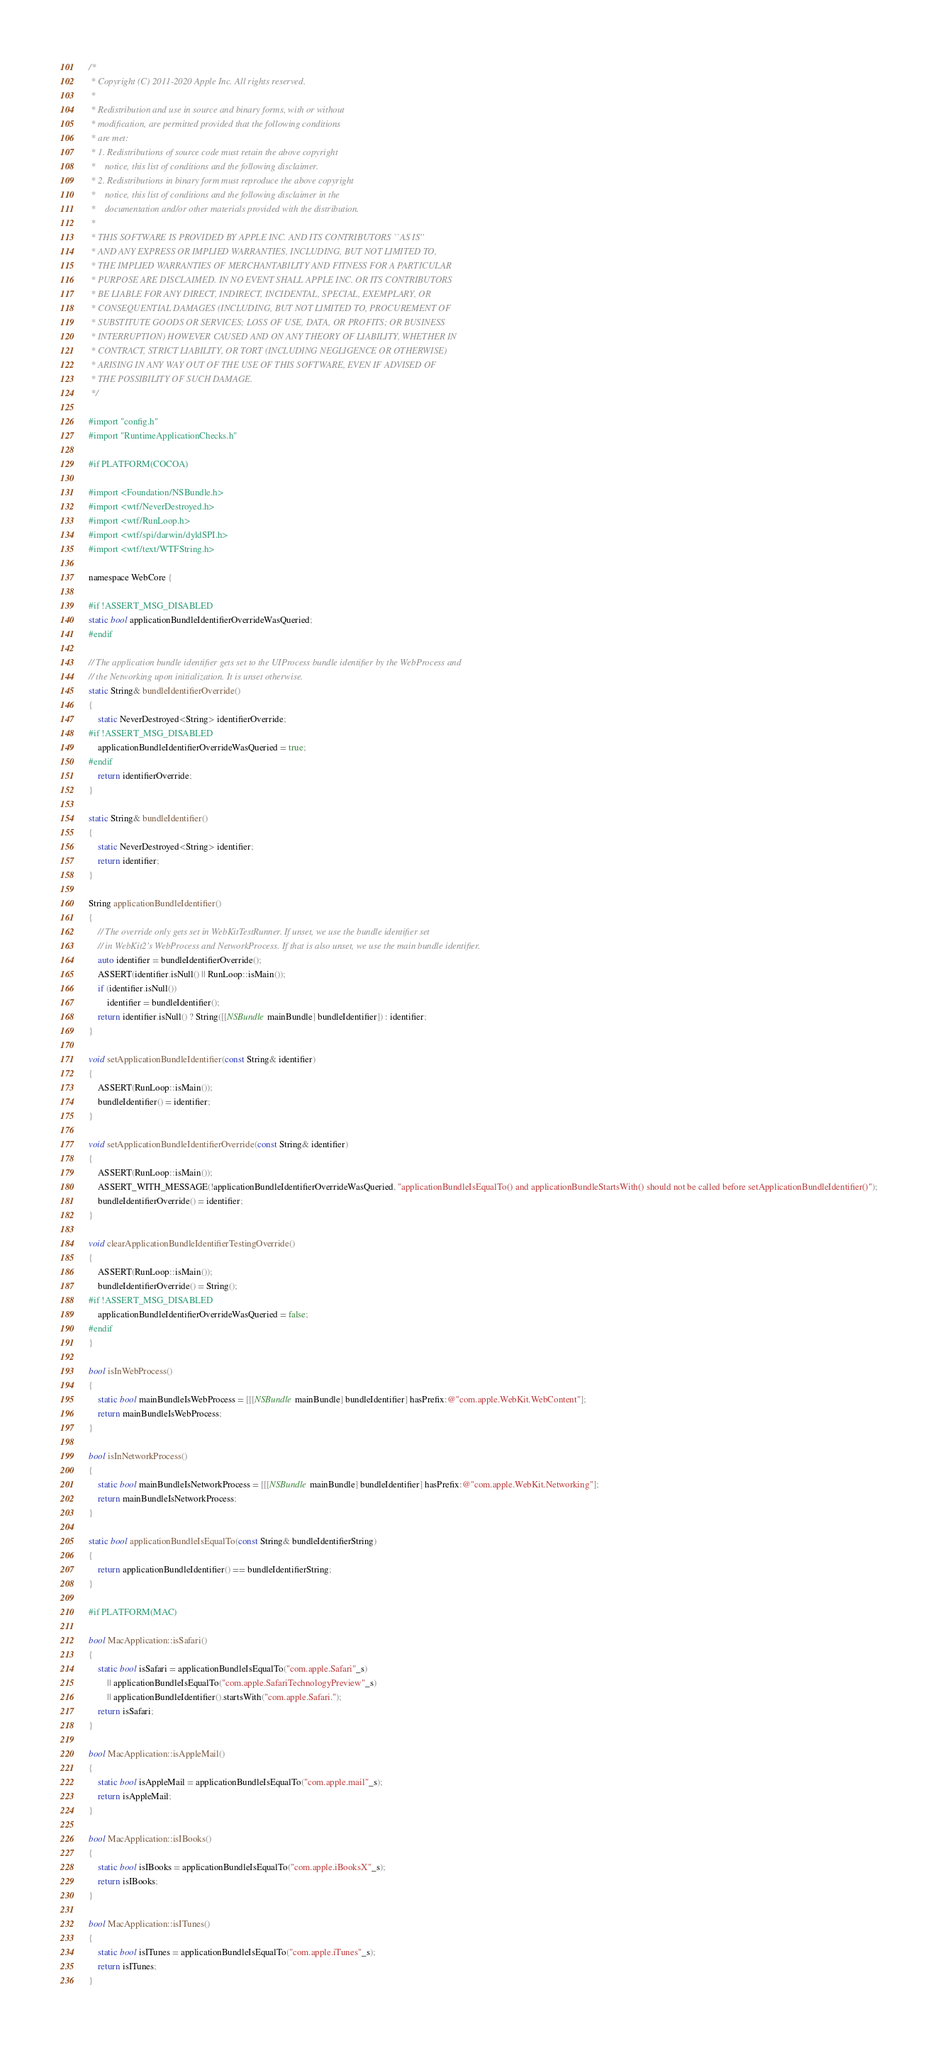Convert code to text. <code><loc_0><loc_0><loc_500><loc_500><_ObjectiveC_>/*
 * Copyright (C) 2011-2020 Apple Inc. All rights reserved.
 *
 * Redistribution and use in source and binary forms, with or without
 * modification, are permitted provided that the following conditions
 * are met:
 * 1. Redistributions of source code must retain the above copyright
 *    notice, this list of conditions and the following disclaimer.
 * 2. Redistributions in binary form must reproduce the above copyright
 *    notice, this list of conditions and the following disclaimer in the
 *    documentation and/or other materials provided with the distribution.
 *
 * THIS SOFTWARE IS PROVIDED BY APPLE INC. AND ITS CONTRIBUTORS ``AS IS''
 * AND ANY EXPRESS OR IMPLIED WARRANTIES, INCLUDING, BUT NOT LIMITED TO,
 * THE IMPLIED WARRANTIES OF MERCHANTABILITY AND FITNESS FOR A PARTICULAR
 * PURPOSE ARE DISCLAIMED. IN NO EVENT SHALL APPLE INC. OR ITS CONTRIBUTORS
 * BE LIABLE FOR ANY DIRECT, INDIRECT, INCIDENTAL, SPECIAL, EXEMPLARY, OR
 * CONSEQUENTIAL DAMAGES (INCLUDING, BUT NOT LIMITED TO, PROCUREMENT OF
 * SUBSTITUTE GOODS OR SERVICES; LOSS OF USE, DATA, OR PROFITS; OR BUSINESS
 * INTERRUPTION) HOWEVER CAUSED AND ON ANY THEORY OF LIABILITY, WHETHER IN
 * CONTRACT, STRICT LIABILITY, OR TORT (INCLUDING NEGLIGENCE OR OTHERWISE)
 * ARISING IN ANY WAY OUT OF THE USE OF THIS SOFTWARE, EVEN IF ADVISED OF
 * THE POSSIBILITY OF SUCH DAMAGE.
 */

#import "config.h"
#import "RuntimeApplicationChecks.h"

#if PLATFORM(COCOA)

#import <Foundation/NSBundle.h>
#import <wtf/NeverDestroyed.h>
#import <wtf/RunLoop.h>
#import <wtf/spi/darwin/dyldSPI.h>
#import <wtf/text/WTFString.h>

namespace WebCore {

#if !ASSERT_MSG_DISABLED
static bool applicationBundleIdentifierOverrideWasQueried;
#endif

// The application bundle identifier gets set to the UIProcess bundle identifier by the WebProcess and
// the Networking upon initialization. It is unset otherwise.
static String& bundleIdentifierOverride()
{
    static NeverDestroyed<String> identifierOverride;
#if !ASSERT_MSG_DISABLED
    applicationBundleIdentifierOverrideWasQueried = true;
#endif
    return identifierOverride;
}

static String& bundleIdentifier()
{
    static NeverDestroyed<String> identifier;
    return identifier;
}

String applicationBundleIdentifier()
{
    // The override only gets set in WebKitTestRunner. If unset, we use the bundle identifier set
    // in WebKit2's WebProcess and NetworkProcess. If that is also unset, we use the main bundle identifier.
    auto identifier = bundleIdentifierOverride();
    ASSERT(identifier.isNull() || RunLoop::isMain());
    if (identifier.isNull())
        identifier = bundleIdentifier();
    return identifier.isNull() ? String([[NSBundle mainBundle] bundleIdentifier]) : identifier;
}

void setApplicationBundleIdentifier(const String& identifier)
{
    ASSERT(RunLoop::isMain());
    bundleIdentifier() = identifier;
}

void setApplicationBundleIdentifierOverride(const String& identifier)
{
    ASSERT(RunLoop::isMain());
    ASSERT_WITH_MESSAGE(!applicationBundleIdentifierOverrideWasQueried, "applicationBundleIsEqualTo() and applicationBundleStartsWith() should not be called before setApplicationBundleIdentifier()");
    bundleIdentifierOverride() = identifier;
}

void clearApplicationBundleIdentifierTestingOverride()
{
    ASSERT(RunLoop::isMain());
    bundleIdentifierOverride() = String();
#if !ASSERT_MSG_DISABLED
    applicationBundleIdentifierOverrideWasQueried = false;
#endif
}

bool isInWebProcess()
{
    static bool mainBundleIsWebProcess = [[[NSBundle mainBundle] bundleIdentifier] hasPrefix:@"com.apple.WebKit.WebContent"];
    return mainBundleIsWebProcess;
}

bool isInNetworkProcess()
{
    static bool mainBundleIsNetworkProcess = [[[NSBundle mainBundle] bundleIdentifier] hasPrefix:@"com.apple.WebKit.Networking"];
    return mainBundleIsNetworkProcess;
}

static bool applicationBundleIsEqualTo(const String& bundleIdentifierString)
{
    return applicationBundleIdentifier() == bundleIdentifierString;
}

#if PLATFORM(MAC)

bool MacApplication::isSafari()
{
    static bool isSafari = applicationBundleIsEqualTo("com.apple.Safari"_s)
        || applicationBundleIsEqualTo("com.apple.SafariTechnologyPreview"_s)
        || applicationBundleIdentifier().startsWith("com.apple.Safari.");
    return isSafari;
}

bool MacApplication::isAppleMail()
{
    static bool isAppleMail = applicationBundleIsEqualTo("com.apple.mail"_s);
    return isAppleMail;
}

bool MacApplication::isIBooks()
{
    static bool isIBooks = applicationBundleIsEqualTo("com.apple.iBooksX"_s);
    return isIBooks;
}

bool MacApplication::isITunes()
{
    static bool isITunes = applicationBundleIsEqualTo("com.apple.iTunes"_s);
    return isITunes;
}
</code> 